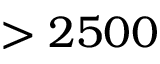<formula> <loc_0><loc_0><loc_500><loc_500>> 2 5 0 0</formula> 